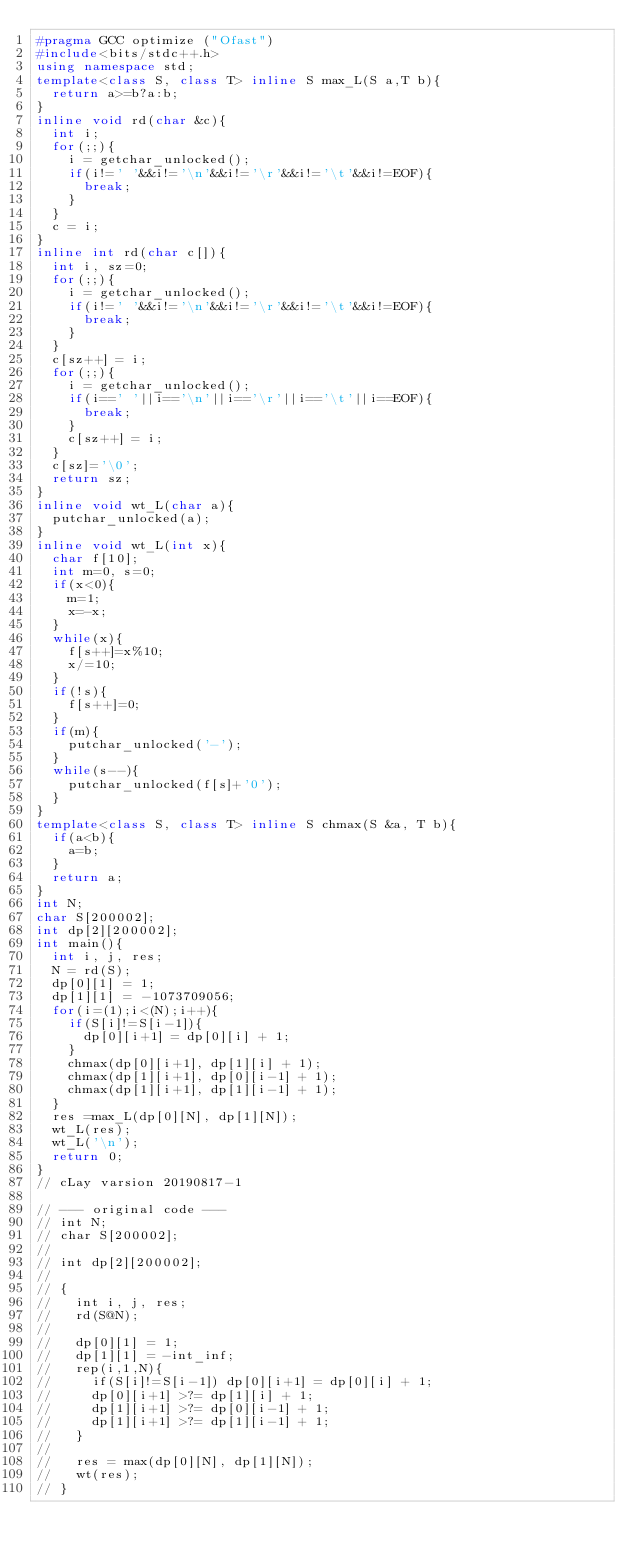<code> <loc_0><loc_0><loc_500><loc_500><_C++_>#pragma GCC optimize ("Ofast")
#include<bits/stdc++.h>
using namespace std;
template<class S, class T> inline S max_L(S a,T b){
  return a>=b?a:b;
}
inline void rd(char &c){
  int i;
  for(;;){
    i = getchar_unlocked();
    if(i!=' '&&i!='\n'&&i!='\r'&&i!='\t'&&i!=EOF){
      break;
    }
  }
  c = i;
}
inline int rd(char c[]){
  int i, sz=0;
  for(;;){
    i = getchar_unlocked();
    if(i!=' '&&i!='\n'&&i!='\r'&&i!='\t'&&i!=EOF){
      break;
    }
  }
  c[sz++] = i;
  for(;;){
    i = getchar_unlocked();
    if(i==' '||i=='\n'||i=='\r'||i=='\t'||i==EOF){
      break;
    }
    c[sz++] = i;
  }
  c[sz]='\0';
  return sz;
}
inline void wt_L(char a){
  putchar_unlocked(a);
}
inline void wt_L(int x){
  char f[10];
  int m=0, s=0;
  if(x<0){
    m=1;
    x=-x;
  }
  while(x){
    f[s++]=x%10;
    x/=10;
  }
  if(!s){
    f[s++]=0;
  }
  if(m){
    putchar_unlocked('-');
  }
  while(s--){
    putchar_unlocked(f[s]+'0');
  }
}
template<class S, class T> inline S chmax(S &a, T b){
  if(a<b){
    a=b;
  }
  return a;
}
int N;
char S[200002];
int dp[2][200002];
int main(){
  int i, j, res;
  N = rd(S);
  dp[0][1] = 1;
  dp[1][1] = -1073709056;
  for(i=(1);i<(N);i++){
    if(S[i]!=S[i-1]){
      dp[0][i+1] = dp[0][i] + 1;
    }
    chmax(dp[0][i+1], dp[1][i] + 1);
    chmax(dp[1][i+1], dp[0][i-1] + 1);
    chmax(dp[1][i+1], dp[1][i-1] + 1);
  }
  res =max_L(dp[0][N], dp[1][N]);
  wt_L(res);
  wt_L('\n');
  return 0;
}
// cLay varsion 20190817-1

// --- original code ---
// int N;
// char S[200002];
// 
// int dp[2][200002];
// 
// {
//   int i, j, res;
//   rd(S@N);
// 
//   dp[0][1] = 1;
//   dp[1][1] = -int_inf;
//   rep(i,1,N){
//     if(S[i]!=S[i-1]) dp[0][i+1] = dp[0][i] + 1;
//     dp[0][i+1] >?= dp[1][i] + 1;
//     dp[1][i+1] >?= dp[0][i-1] + 1;
//     dp[1][i+1] >?= dp[1][i-1] + 1;
//   }
// 
//   res = max(dp[0][N], dp[1][N]);
//   wt(res);
// }
</code> 